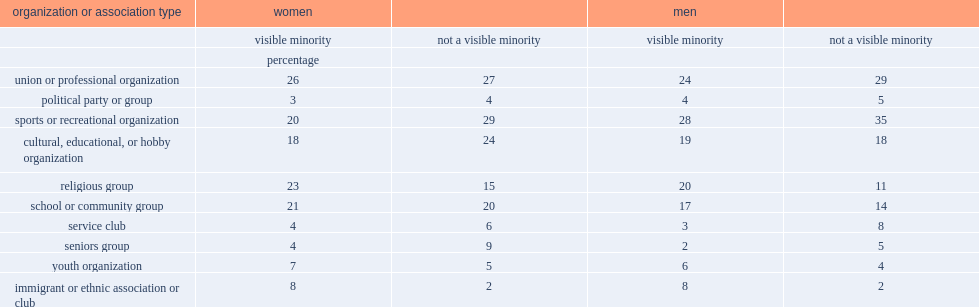What was the percent of visible minority women participated in such an organization? 26.0. What was the percentage of women who were not a visible minority participated in such an organization? 27.0. Which type of men were more likely to be involved in a school or community group, visible minority or not a visible minority? Visible minority. Which type of men were less likely to be involved in a union or professional organization, visible minority or not a visible minority? Visible minority. 